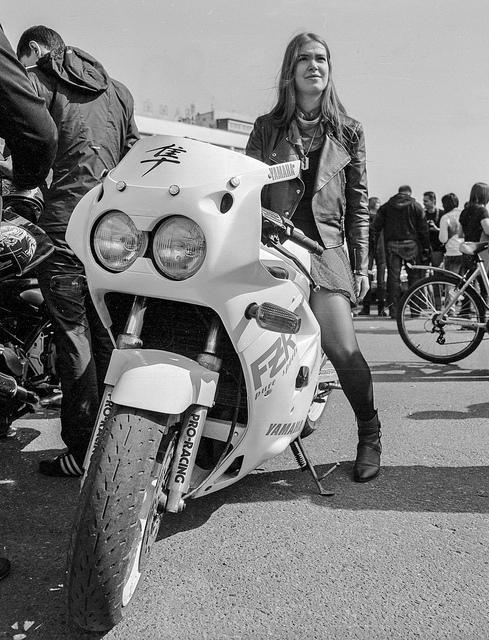Was this photo taken in the year 2029?
Answer briefly. No. Is the woman wearing boots?
Concise answer only. Yes. Where is an American flag in the picture?
Write a very short answer. Nowhere. Who is riding the motorcycle?
Keep it brief. Woman. How long is the rider's hair?
Keep it brief. Long. Is that a man or woman?
Short answer required. Woman. Is the woman riding the motorcycle?
Write a very short answer. No. 